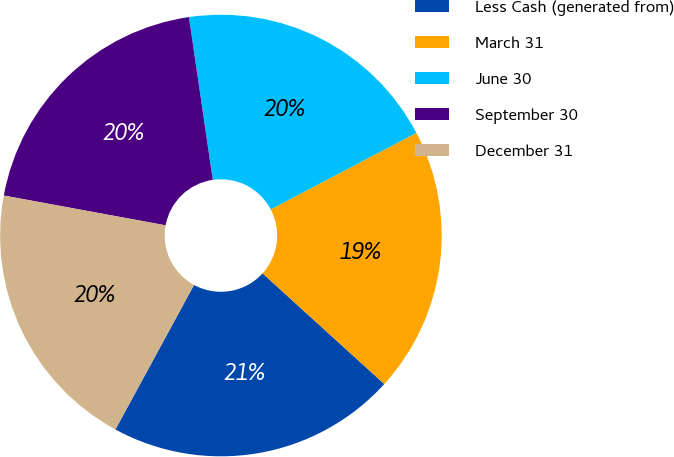<chart> <loc_0><loc_0><loc_500><loc_500><pie_chart><fcel>Less Cash (generated from)<fcel>March 31<fcel>June 30<fcel>September 30<fcel>December 31<nl><fcel>21.19%<fcel>19.44%<fcel>19.62%<fcel>19.79%<fcel>19.97%<nl></chart> 